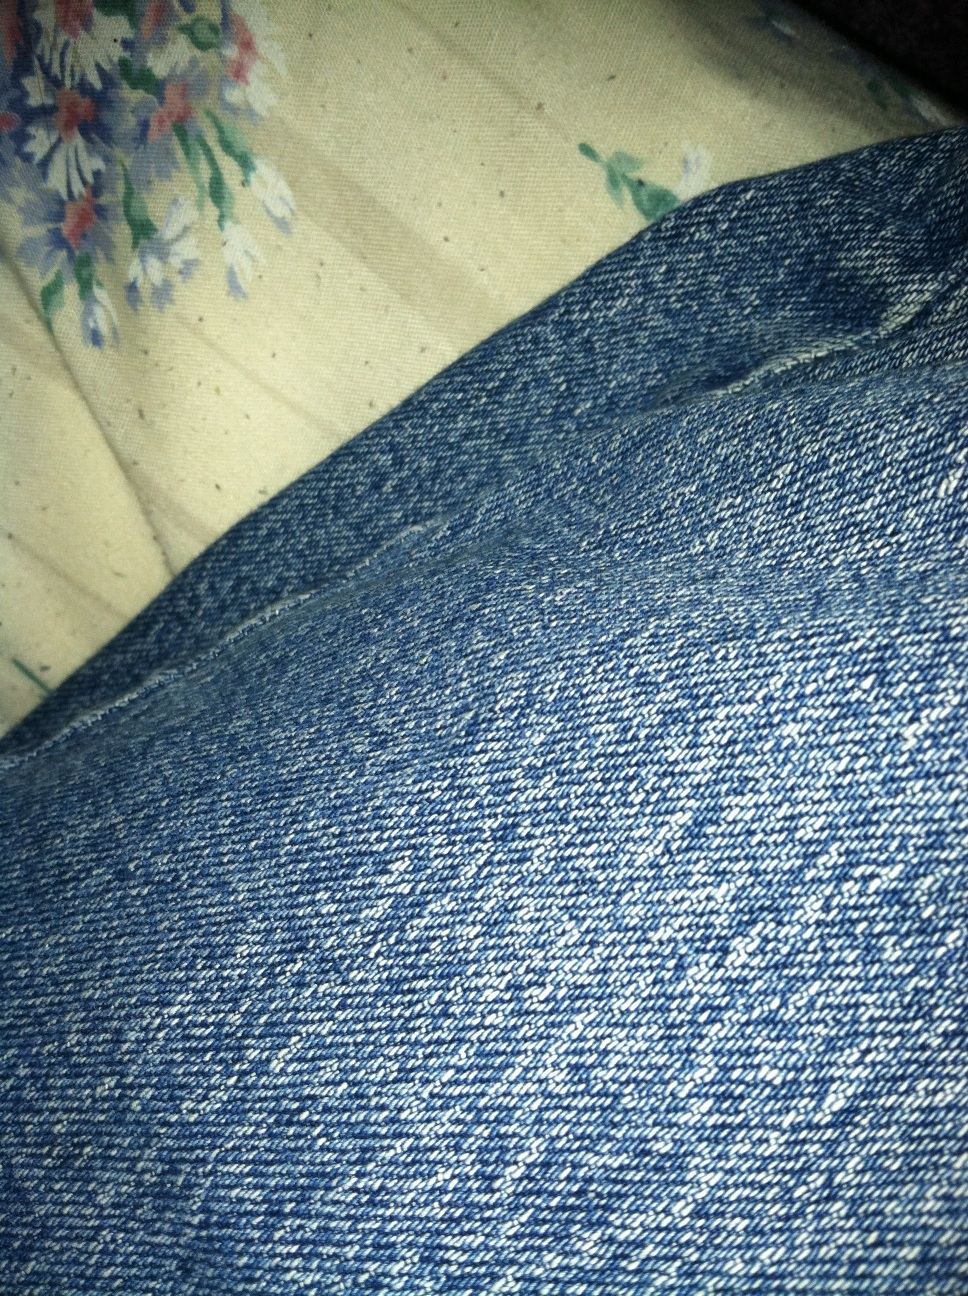Can you describe the texture of these jeans? The texture of these jeans appears to be typical of denim fabric, which is known for its rugged and somewhat coarse feel. The weave is tight and durable, designed to withstand heavy use while becoming softer with wear. Do you think these jeans would be comfortable to wear? Denim jeans are generally comfortable to wear, especially after they've been broken in. Initially, they might feel a bit stiff due to the sturdy fabric, but over time and with repeated wearing and washing, they tend to become softer and more fitting to the body. 